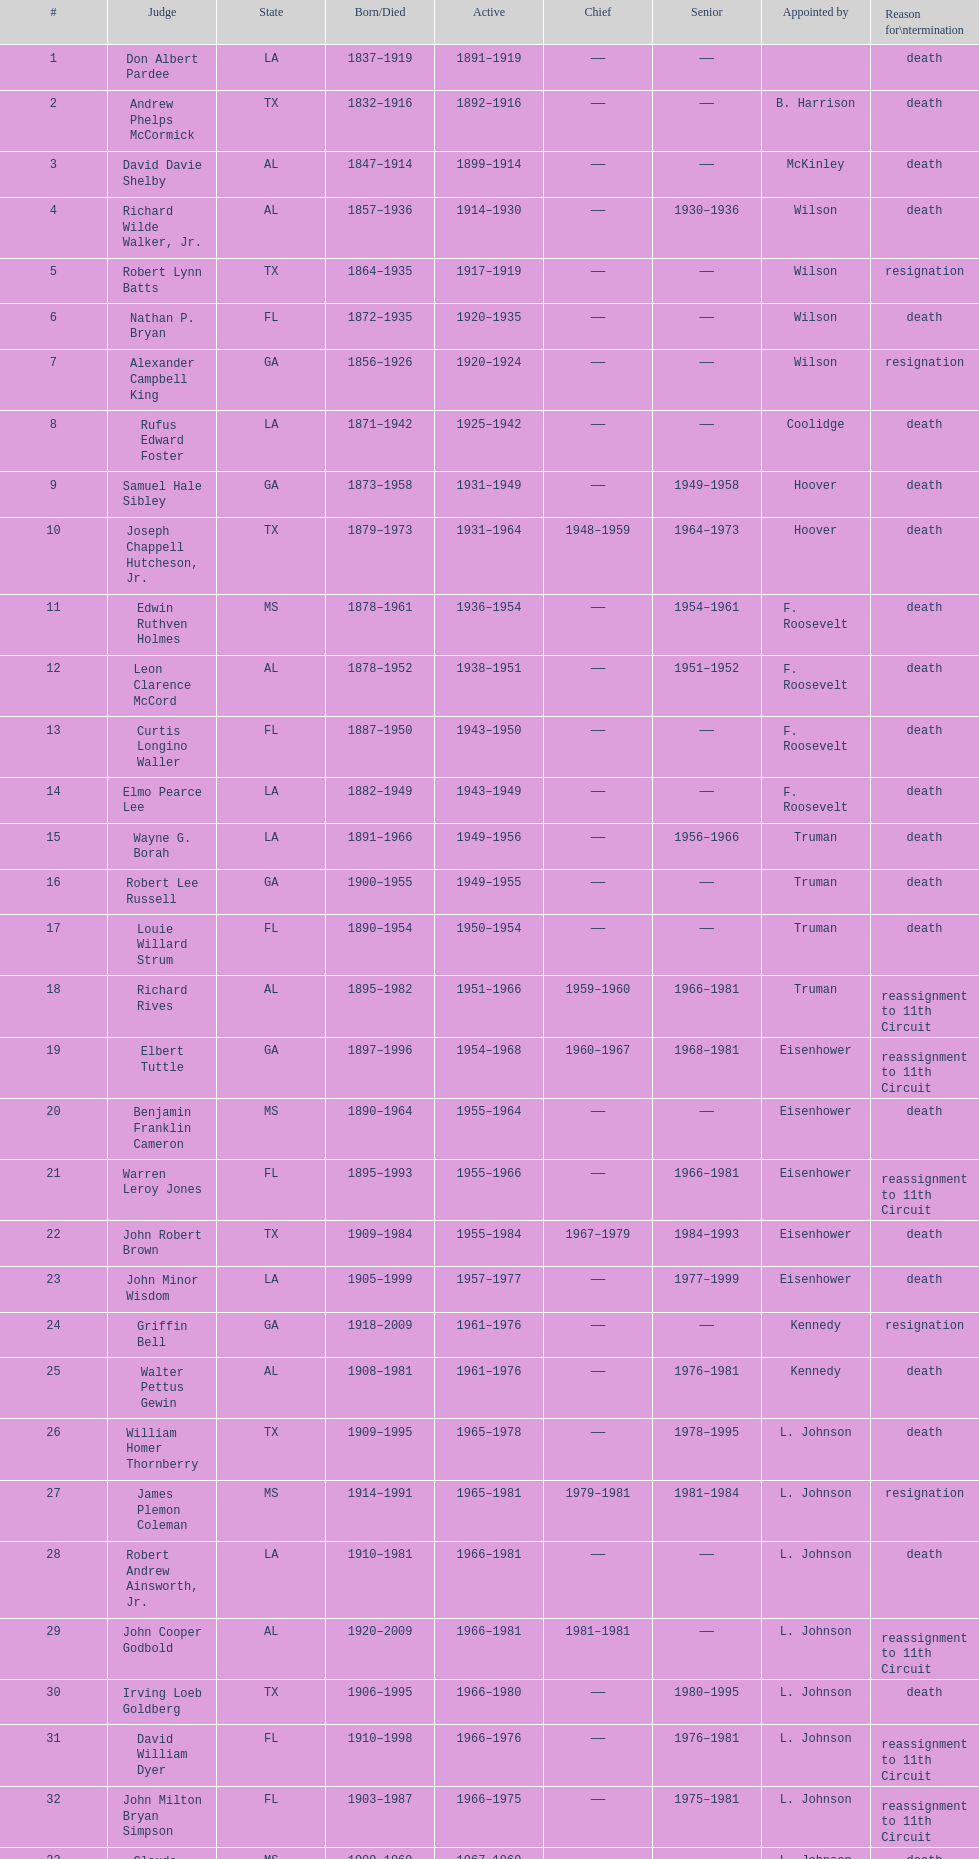Could you parse the entire table? {'header': ['#', 'Judge', 'State', 'Born/Died', 'Active', 'Chief', 'Senior', 'Appointed by', 'Reason for\\ntermination'], 'rows': [['1', 'Don Albert Pardee', 'LA', '1837–1919', '1891–1919', '——', '——', '', 'death'], ['2', 'Andrew Phelps McCormick', 'TX', '1832–1916', '1892–1916', '——', '——', 'B. Harrison', 'death'], ['3', 'David Davie Shelby', 'AL', '1847–1914', '1899–1914', '——', '——', 'McKinley', 'death'], ['4', 'Richard Wilde Walker, Jr.', 'AL', '1857–1936', '1914–1930', '——', '1930–1936', 'Wilson', 'death'], ['5', 'Robert Lynn Batts', 'TX', '1864–1935', '1917–1919', '——', '——', 'Wilson', 'resignation'], ['6', 'Nathan P. Bryan', 'FL', '1872–1935', '1920–1935', '——', '——', 'Wilson', 'death'], ['7', 'Alexander Campbell King', 'GA', '1856–1926', '1920–1924', '——', '——', 'Wilson', 'resignation'], ['8', 'Rufus Edward Foster', 'LA', '1871–1942', '1925–1942', '——', '——', 'Coolidge', 'death'], ['9', 'Samuel Hale Sibley', 'GA', '1873–1958', '1931–1949', '——', '1949–1958', 'Hoover', 'death'], ['10', 'Joseph Chappell Hutcheson, Jr.', 'TX', '1879–1973', '1931–1964', '1948–1959', '1964–1973', 'Hoover', 'death'], ['11', 'Edwin Ruthven Holmes', 'MS', '1878–1961', '1936–1954', '——', '1954–1961', 'F. Roosevelt', 'death'], ['12', 'Leon Clarence McCord', 'AL', '1878–1952', '1938–1951', '——', '1951–1952', 'F. Roosevelt', 'death'], ['13', 'Curtis Longino Waller', 'FL', '1887–1950', '1943–1950', '——', '——', 'F. Roosevelt', 'death'], ['14', 'Elmo Pearce Lee', 'LA', '1882–1949', '1943–1949', '——', '——', 'F. Roosevelt', 'death'], ['15', 'Wayne G. Borah', 'LA', '1891–1966', '1949–1956', '——', '1956–1966', 'Truman', 'death'], ['16', 'Robert Lee Russell', 'GA', '1900–1955', '1949–1955', '——', '——', 'Truman', 'death'], ['17', 'Louie Willard Strum', 'FL', '1890–1954', '1950–1954', '——', '——', 'Truman', 'death'], ['18', 'Richard Rives', 'AL', '1895–1982', '1951–1966', '1959–1960', '1966–1981', 'Truman', 'reassignment to 11th Circuit'], ['19', 'Elbert Tuttle', 'GA', '1897–1996', '1954–1968', '1960–1967', '1968–1981', 'Eisenhower', 'reassignment to 11th Circuit'], ['20', 'Benjamin Franklin Cameron', 'MS', '1890–1964', '1955–1964', '——', '——', 'Eisenhower', 'death'], ['21', 'Warren Leroy Jones', 'FL', '1895–1993', '1955–1966', '——', '1966–1981', 'Eisenhower', 'reassignment to 11th Circuit'], ['22', 'John Robert Brown', 'TX', '1909–1984', '1955–1984', '1967–1979', '1984–1993', 'Eisenhower', 'death'], ['23', 'John Minor Wisdom', 'LA', '1905–1999', '1957–1977', '——', '1977–1999', 'Eisenhower', 'death'], ['24', 'Griffin Bell', 'GA', '1918–2009', '1961–1976', '——', '——', 'Kennedy', 'resignation'], ['25', 'Walter Pettus Gewin', 'AL', '1908–1981', '1961–1976', '——', '1976–1981', 'Kennedy', 'death'], ['26', 'William Homer Thornberry', 'TX', '1909–1995', '1965–1978', '——', '1978–1995', 'L. Johnson', 'death'], ['27', 'James Plemon Coleman', 'MS', '1914–1991', '1965–1981', '1979–1981', '1981–1984', 'L. Johnson', 'resignation'], ['28', 'Robert Andrew Ainsworth, Jr.', 'LA', '1910–1981', '1966–1981', '——', '——', 'L. Johnson', 'death'], ['29', 'John Cooper Godbold', 'AL', '1920–2009', '1966–1981', '1981–1981', '——', 'L. Johnson', 'reassignment to 11th Circuit'], ['30', 'Irving Loeb Goldberg', 'TX', '1906–1995', '1966–1980', '——', '1980–1995', 'L. Johnson', 'death'], ['31', 'David William Dyer', 'FL', '1910–1998', '1966–1976', '——', '1976–1981', 'L. Johnson', 'reassignment to 11th Circuit'], ['32', 'John Milton Bryan Simpson', 'FL', '1903–1987', '1966–1975', '——', '1975–1981', 'L. Johnson', 'reassignment to 11th Circuit'], ['33', 'Claude Feemster Clayton', 'MS', '1909–1969', '1967–1969', '——', '——', 'L. Johnson', 'death'], ['34', 'Lewis Render Morgan', 'GA', '1913–2001', '1968–1978', '——', '1978–1981', 'L. Johnson', 'reassignment to 11th Circuit'], ['35', 'Harold Carswell', 'FL', '1919–1992', '1969–1970', '——', '——', 'Nixon', 'resignation'], ['36', 'Charles Clark', 'MS', '1925–2011', '1969–1992', '1981–1992', '——', 'Nixon', 'retirement'], ['37', 'Joe McDonald Ingraham', 'TX', '1903–1990', '1969–1973', '——', '1973–1990', 'Nixon', 'death'], ['38', 'Paul Hitch Roney', 'FL', '1921–2006', '1970–1981', '——', '——', 'Nixon', 'reassignment to 11th Circuit'], ['39', 'Thomas Gibbs Gee', 'TX', '1925–1994', '1973–1991', '——', '——', 'Nixon', 'retirement'], ['40', 'Gerald Bard Tjoflat', 'FL', '1929–', '1975–1981', '——', '——', 'Ford', 'reassignment to 11th Circuit'], ['41', 'James Clinkscales Hill', 'GA', '1924–', '1976–1981', '——', '——', 'Ford', 'reassignment to 11th Circuit'], ['42', 'Peter Thorp Fay', 'FL', '1929–', '1976–1981', '——', '——', 'Ford', 'reassignment to 11th Circuit'], ['43', 'Alvin Benjamin Rubin', 'LA', '1920–1991', '1977–1989', '——', '1989–1991', 'Carter', 'death'], ['44', 'Robert Smith Vance', 'AL', '1931–1989', '1977–1981', '——', '——', 'Carter', 'reassignment to 11th Circuit'], ['45', 'Phyllis A. Kravitch', 'GA', '1920–', '1979–1981', '——', '——', 'Carter', 'reassignment to 11th Circuit'], ['46', 'Frank Minis Johnson', 'AL', '1918–1999', '1979–1981', '——', '——', 'Carter', 'reassignment to 11th Circuit'], ['47', 'R. Lanier Anderson III', 'GA', '1936–', '1979–1981', '——', '——', 'Carter', 'reassignment to 11th Circuit'], ['48', 'Reynaldo Guerra Garza', 'TX', '1915–2004', '1979–1982', '——', '1982–2004', 'Carter', 'death'], ['49', 'Joseph Woodrow Hatchett', 'FL', '1932–', '1979–1981', '——', '——', 'Carter', 'reassignment to 11th Circuit'], ['50', 'Albert John Henderson', 'GA', '1920–1999', '1979–1981', '——', '——', 'Carter', 'reassignment to 11th Circuit'], ['52', 'Henry Anthony Politz', 'LA', '1932–2002', '1979–1999', '1992–1999', '1999–2002', 'Carter', 'death'], ['54', 'Samuel D. Johnson, Jr.', 'TX', '1920–2002', '1979–1991', '——', '1991–2002', 'Carter', 'death'], ['55', 'Albert Tate, Jr.', 'LA', '1920–1986', '1979–1986', '——', '——', 'Carter', 'death'], ['56', 'Thomas Alonzo Clark', 'GA', '1920–2005', '1979–1981', '——', '——', 'Carter', 'reassignment to 11th Circuit'], ['57', 'Jerre Stockton Williams', 'TX', '1916–1993', '1980–1990', '——', '1990–1993', 'Carter', 'death'], ['58', 'William Lockhart Garwood', 'TX', '1931–2011', '1981–1997', '——', '1997–2011', 'Reagan', 'death'], ['62', 'Robert Madden Hill', 'TX', '1928–1987', '1984–1987', '——', '——', 'Reagan', 'death'], ['65', 'John Malcolm Duhé, Jr.', 'LA', '1933-', '1988–1999', '——', '1999–2011', 'Reagan', 'retirement'], ['72', 'Robert Manley Parker', 'TX', '1937–', '1994–2002', '——', '——', 'Clinton', 'retirement'], ['76', 'Charles W. Pickering', 'MS', '1937–', '2004–2004', '——', '——', 'G.W. Bush', 'retirement']]} Which state has the largest amount of judges to serve? TX. 